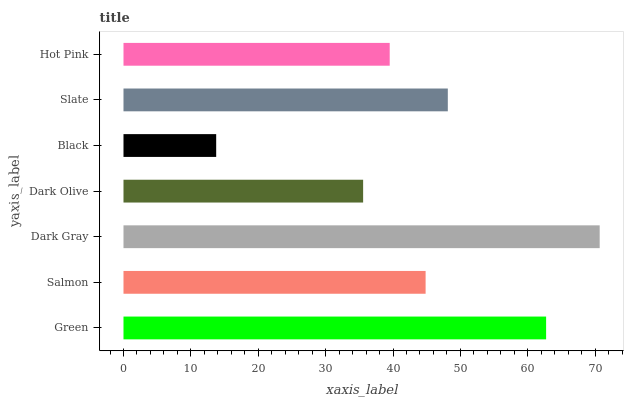Is Black the minimum?
Answer yes or no. Yes. Is Dark Gray the maximum?
Answer yes or no. Yes. Is Salmon the minimum?
Answer yes or no. No. Is Salmon the maximum?
Answer yes or no. No. Is Green greater than Salmon?
Answer yes or no. Yes. Is Salmon less than Green?
Answer yes or no. Yes. Is Salmon greater than Green?
Answer yes or no. No. Is Green less than Salmon?
Answer yes or no. No. Is Salmon the high median?
Answer yes or no. Yes. Is Salmon the low median?
Answer yes or no. Yes. Is Green the high median?
Answer yes or no. No. Is Dark Gray the low median?
Answer yes or no. No. 